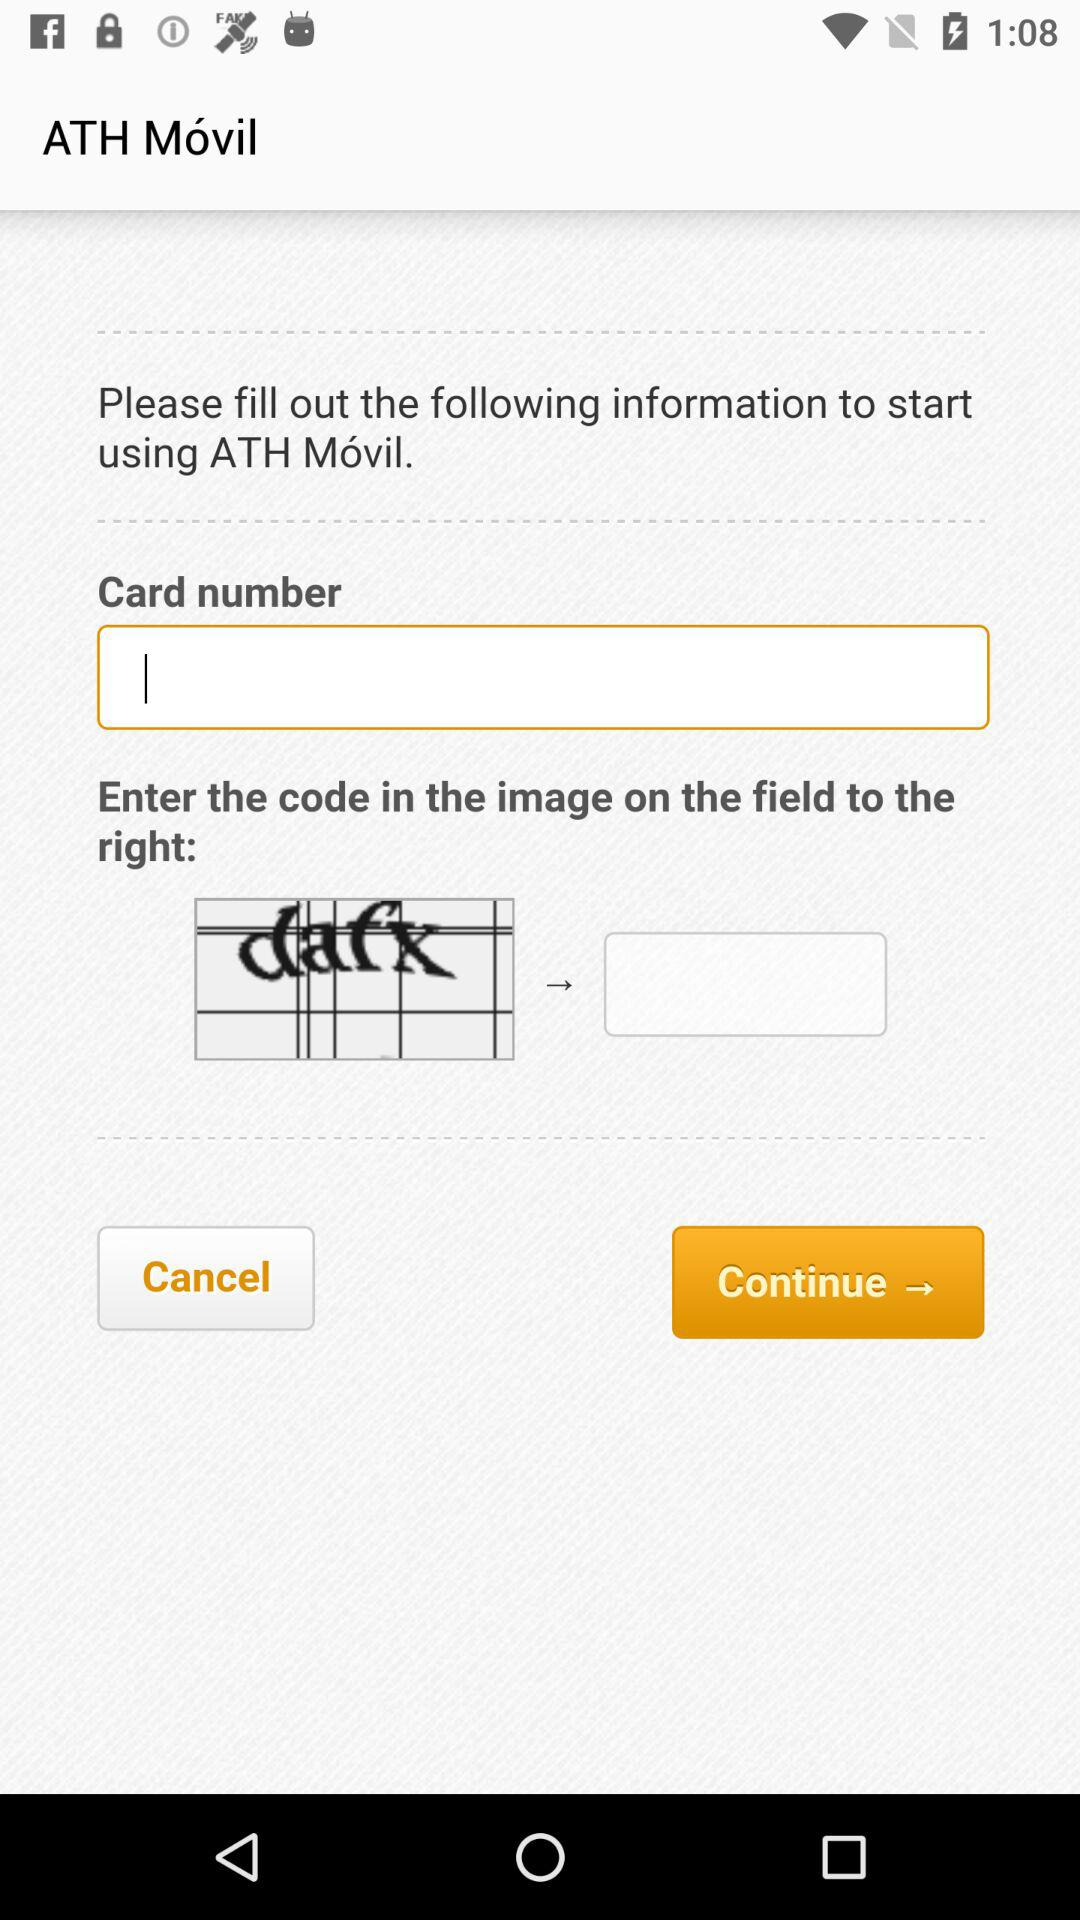What is the code shown in the image? The code is "dafx". 